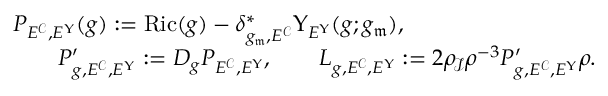<formula> <loc_0><loc_0><loc_500><loc_500>\begin{array} { r l } & { P _ { E ^ { \mathcal { C } } , E ^ { \Upsilon } } ( g ) \colon = R i c ( g ) - \delta _ { g _ { \mathfrak { m } } , E ^ { \mathcal { C } } } ^ { * } \Upsilon _ { E ^ { \Upsilon } } ( g ; g _ { \mathfrak { m } } ) , } \\ & { \quad P _ { g , E ^ { \mathcal { C } } , E ^ { \Upsilon } } ^ { \prime } \colon = D _ { g } P _ { E ^ { \mathcal { C } } , E ^ { \Upsilon } } , \quad L _ { g , E ^ { \mathcal { C } } , E ^ { \Upsilon } } \colon = 2 \rho _ { \, \ m a t h s c r I } \rho ^ { - 3 } P _ { g , E ^ { \mathcal { C } } , E ^ { \Upsilon } } ^ { \prime } \rho . } \end{array}</formula> 